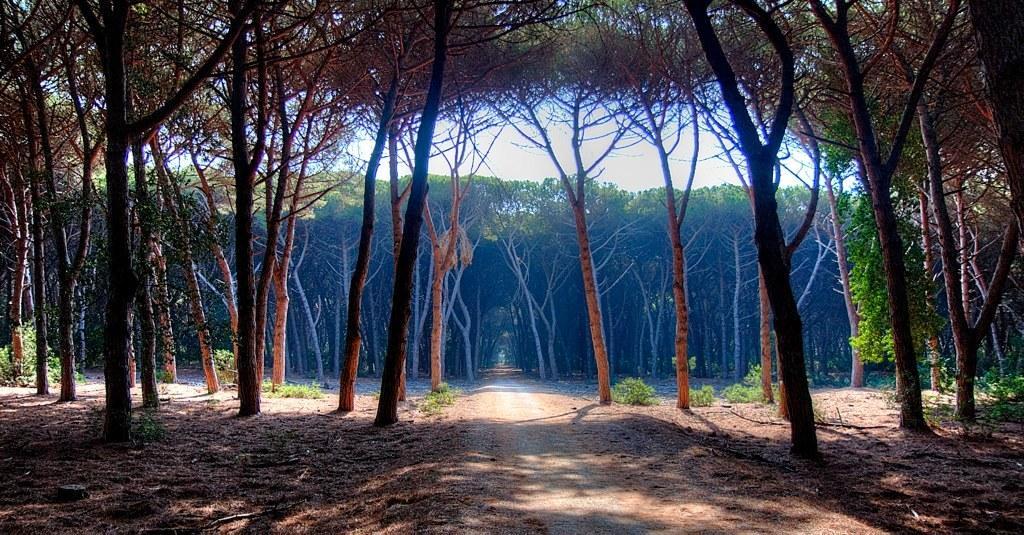Please provide a concise description of this image. In this image I can see trees and the sky at the top and there is a rope in the middle. 